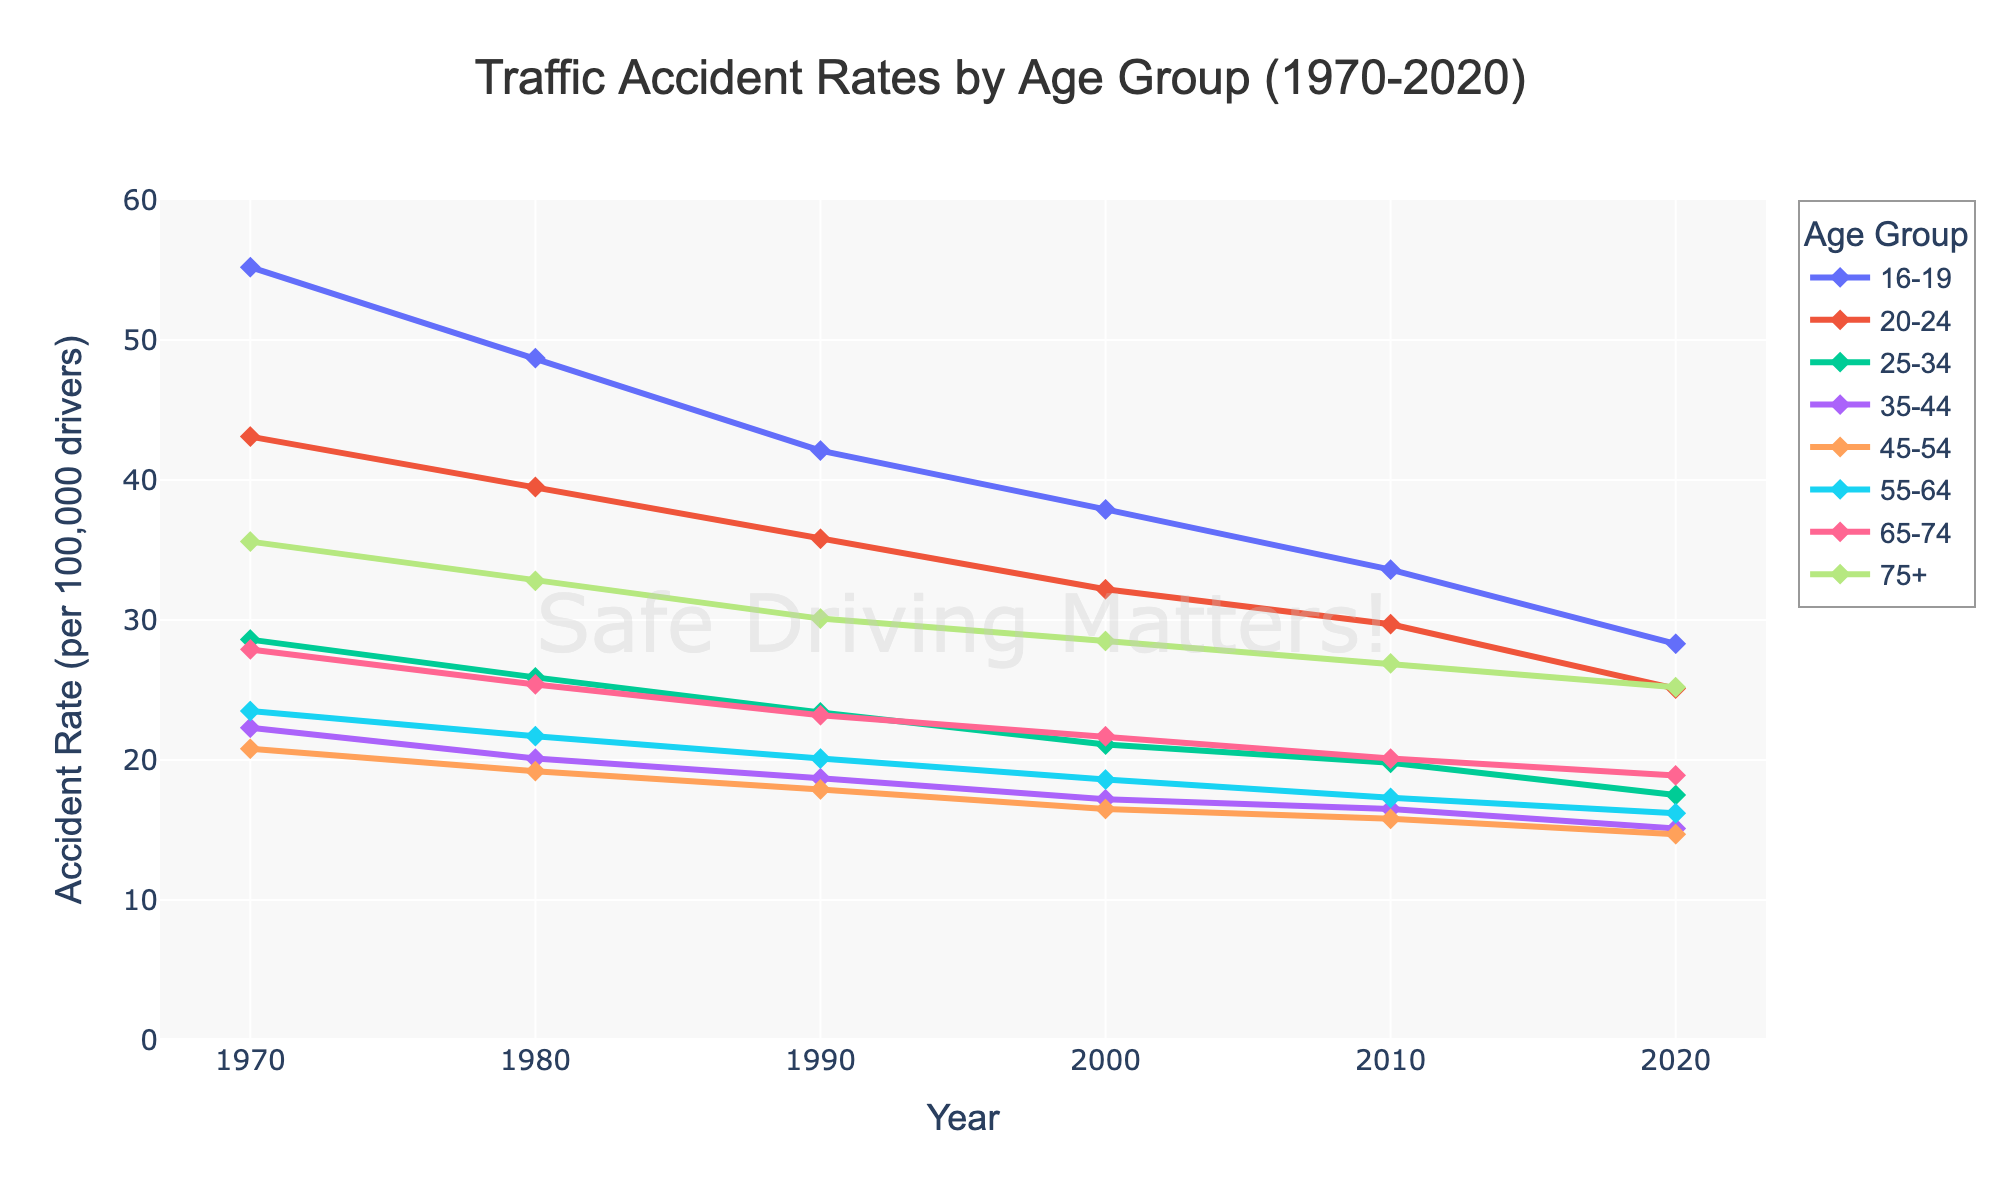What is the accident rate for the 55-64 age group in 1990? Identify the line for the 55-64 age group and look for the marker corresponding to the year 1990, which indicates an accident rate of 20.1.
Answer: 20.1 How much did the accident rate for the 16-19 age group decrease from 1970 to 2020? Subtract the accident rate in 2020 (28.3) from the rate in 1970 (55.2) for the 16-19 age group: 55.2 - 28.3 = 26.9.
Answer: 26.9 Which age group had the highest accident rate in 2020? Find the highest point among the lines for the year 2020. The 16-19 age group had the highest rate in 2020 with an accident rate of 28.3.
Answer: 16-19 Compare the accident rates of the 25-34 and 75+ age groups in 1980. Which one was higher? Locate the markers for the 25-34 and 75+ age groups in 1980. The 75+ age group had an accident rate of 32.8, while the 25-34 age group had a rate of 25.9. Thus, the 75+ age group's rate was higher.
Answer: 75+ What is the overall trend in accident rates for the 35-44 age group from 1970 to 2020? Observe the line for the 35-44 age group. The line consistently decreases from 1970 (22.3) to 2020 (15.1), indicating a general downward trend.
Answer: Downward Which two age groups have similar accident rates in 2010? Check the points for 2010 for all age groups. The 35-44 (16.5) and 45-54 (15.8) age groups have similar rates.
Answer: 35-44 and 45-54 Calculate the average accident rate for the 75+ age group from 1970 to 2020. Add the accident rates for the 75+ age group across all years and divide by the number of years: (35.6 + 32.8 + 30.1 + 28.5 + 26.9 + 25.2) / 6 = 29.85.
Answer: 29.85 Between which years did the 20-24 age group see the largest drop in accident rates? Compare the differences in accident rates between consecutive decades for the 20-24 age group. The largest drop is between 2010 and 2020, with a change from 29.7 to 25.1, a reduction of 4.6.
Answer: 2010 to 2020 For the 16-19 age group, what is the difference in accident rates between 1980 and 2000? Subtract the accident rate in 2000 (37.9) from the rate in 1980 (48.7) for the 16-19 age group: 48.7 - 37.9 = 10.8.
Answer: 10.8 How do the accident rates for the 65-74 age group in 1970 compare to those in 2020? Find the markers for the 65-74 age group in 1970 (27.9) and 2020 (18.9). The rate in 1970 is higher than in 2020.
Answer: Higher in 1970 